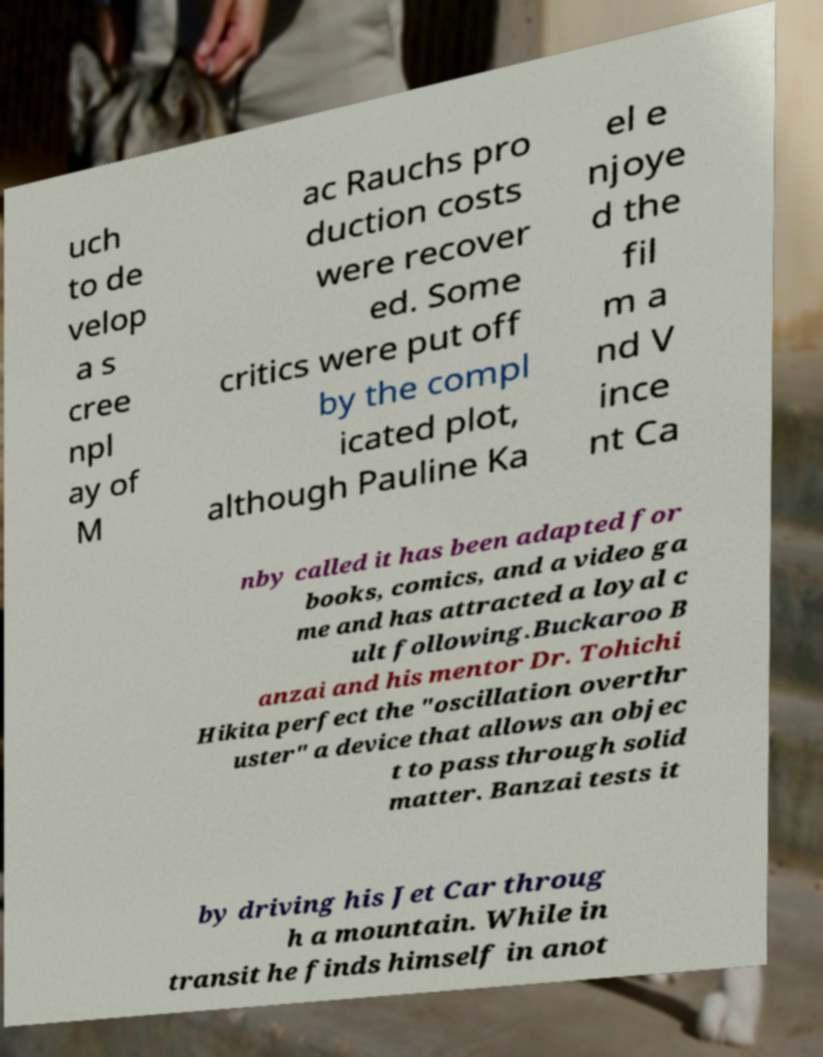Please identify and transcribe the text found in this image. uch to de velop a s cree npl ay of M ac Rauchs pro duction costs were recover ed. Some critics were put off by the compl icated plot, although Pauline Ka el e njoye d the fil m a nd V ince nt Ca nby called it has been adapted for books, comics, and a video ga me and has attracted a loyal c ult following.Buckaroo B anzai and his mentor Dr. Tohichi Hikita perfect the "oscillation overthr uster" a device that allows an objec t to pass through solid matter. Banzai tests it by driving his Jet Car throug h a mountain. While in transit he finds himself in anot 